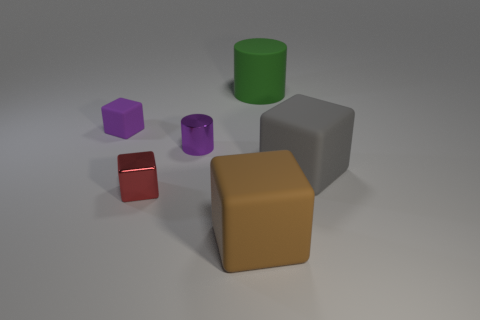Does anything in this image indicate motion or activity? The image appears static without any direct indications of motion or activity. All objects are at rest, with stable, upright positions and shadows that suggest no recent movement or interaction. 